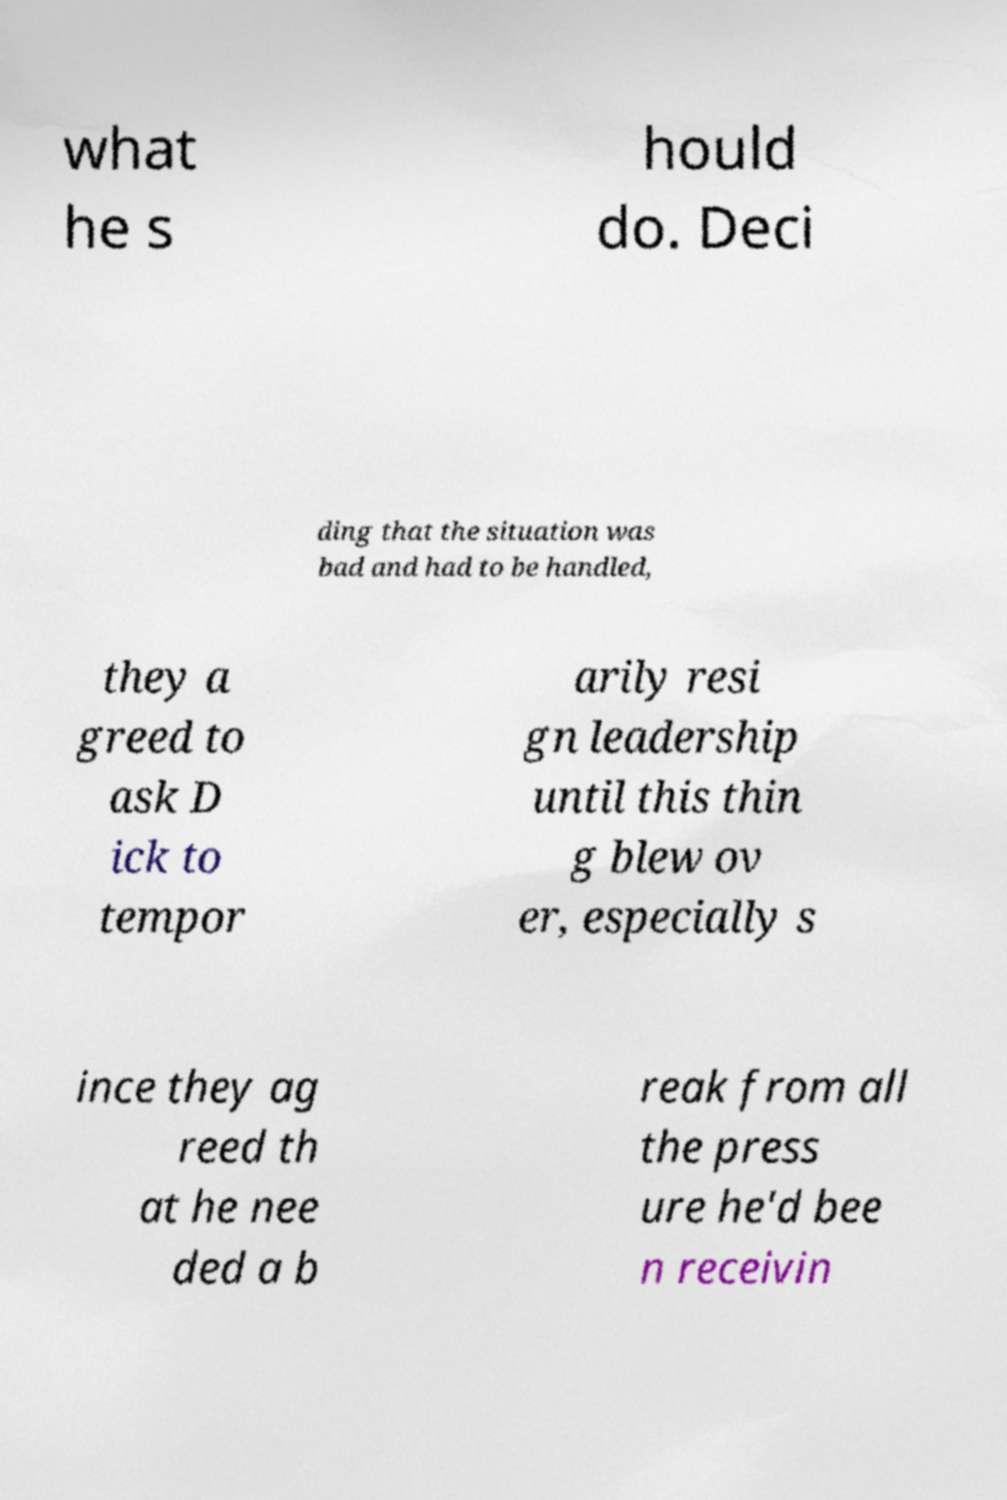Can you read and provide the text displayed in the image?This photo seems to have some interesting text. Can you extract and type it out for me? what he s hould do. Deci ding that the situation was bad and had to be handled, they a greed to ask D ick to tempor arily resi gn leadership until this thin g blew ov er, especially s ince they ag reed th at he nee ded a b reak from all the press ure he'd bee n receivin 